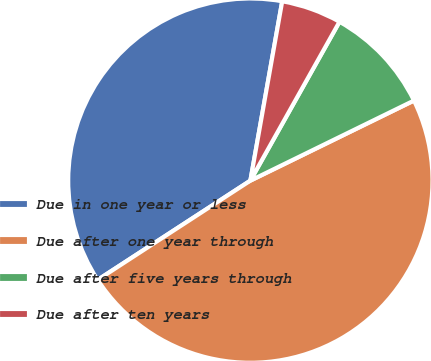Convert chart. <chart><loc_0><loc_0><loc_500><loc_500><pie_chart><fcel>Due in one year or less<fcel>Due after one year through<fcel>Due after five years through<fcel>Due after ten years<nl><fcel>36.97%<fcel>48.07%<fcel>9.62%<fcel>5.34%<nl></chart> 